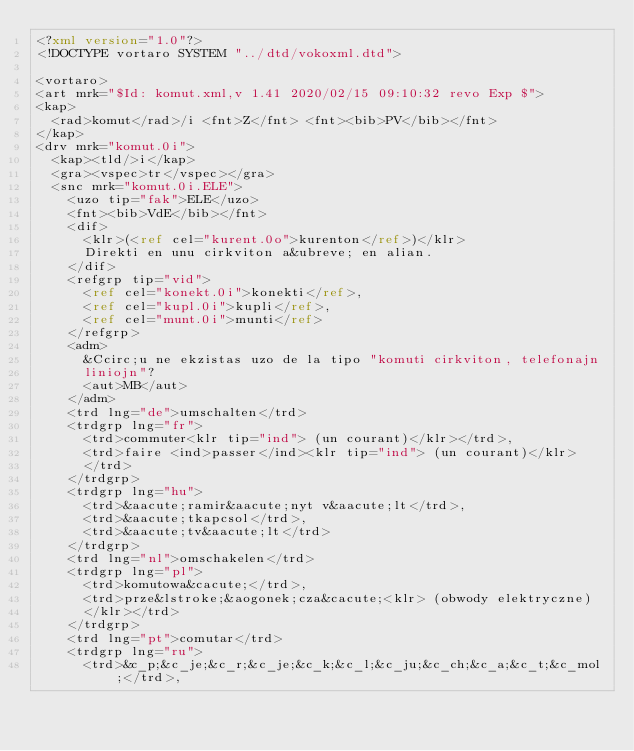Convert code to text. <code><loc_0><loc_0><loc_500><loc_500><_XML_><?xml version="1.0"?>
<!DOCTYPE vortaro SYSTEM "../dtd/vokoxml.dtd">

<vortaro>
<art mrk="$Id: komut.xml,v 1.41 2020/02/15 09:10:32 revo Exp $">
<kap>
  <rad>komut</rad>/i <fnt>Z</fnt> <fnt><bib>PV</bib></fnt>
</kap>
<drv mrk="komut.0i">
  <kap><tld/>i</kap>
  <gra><vspec>tr</vspec></gra>
  <snc mrk="komut.0i.ELE">
    <uzo tip="fak">ELE</uzo>
    <fnt><bib>VdE</bib></fnt>
    <dif>
      <klr>(<ref cel="kurent.0o">kurenton</ref>)</klr>
      Direkti en unu cirkviton a&ubreve; en alian.
    </dif>
    <refgrp tip="vid">
      <ref cel="konekt.0i">konekti</ref>,
      <ref cel="kupl.0i">kupli</ref>,
      <ref cel="munt.0i">munti</ref>
    </refgrp>
    <adm>
      &Ccirc;u ne ekzistas uzo de la tipo "komuti cirkviton, telefonajn
      liniojn"?
      <aut>MB</aut>
    </adm>
    <trd lng="de">umschalten</trd>
    <trdgrp lng="fr">
      <trd>commuter<klr tip="ind"> (un courant)</klr></trd>,
      <trd>faire <ind>passer</ind><klr tip="ind"> (un courant)</klr>
      </trd>
    </trdgrp>
    <trdgrp lng="hu">
      <trd>&aacute;ramir&aacute;nyt v&aacute;lt</trd>,
      <trd>&aacute;tkapcsol</trd>,
      <trd>&aacute;tv&aacute;lt</trd>
    </trdgrp>
    <trd lng="nl">omschakelen</trd>
    <trdgrp lng="pl">
      <trd>komutowa&cacute;</trd>,
      <trd>prze&lstroke;&aogonek;cza&cacute;<klr> (obwody elektryczne)
      </klr></trd>
    </trdgrp>
    <trd lng="pt">comutar</trd>
    <trdgrp lng="ru">
      <trd>&c_p;&c_je;&c_r;&c_je;&c_k;&c_l;&c_ju;&c_ch;&c_a;&c_t;&c_mol;</trd>,</code> 